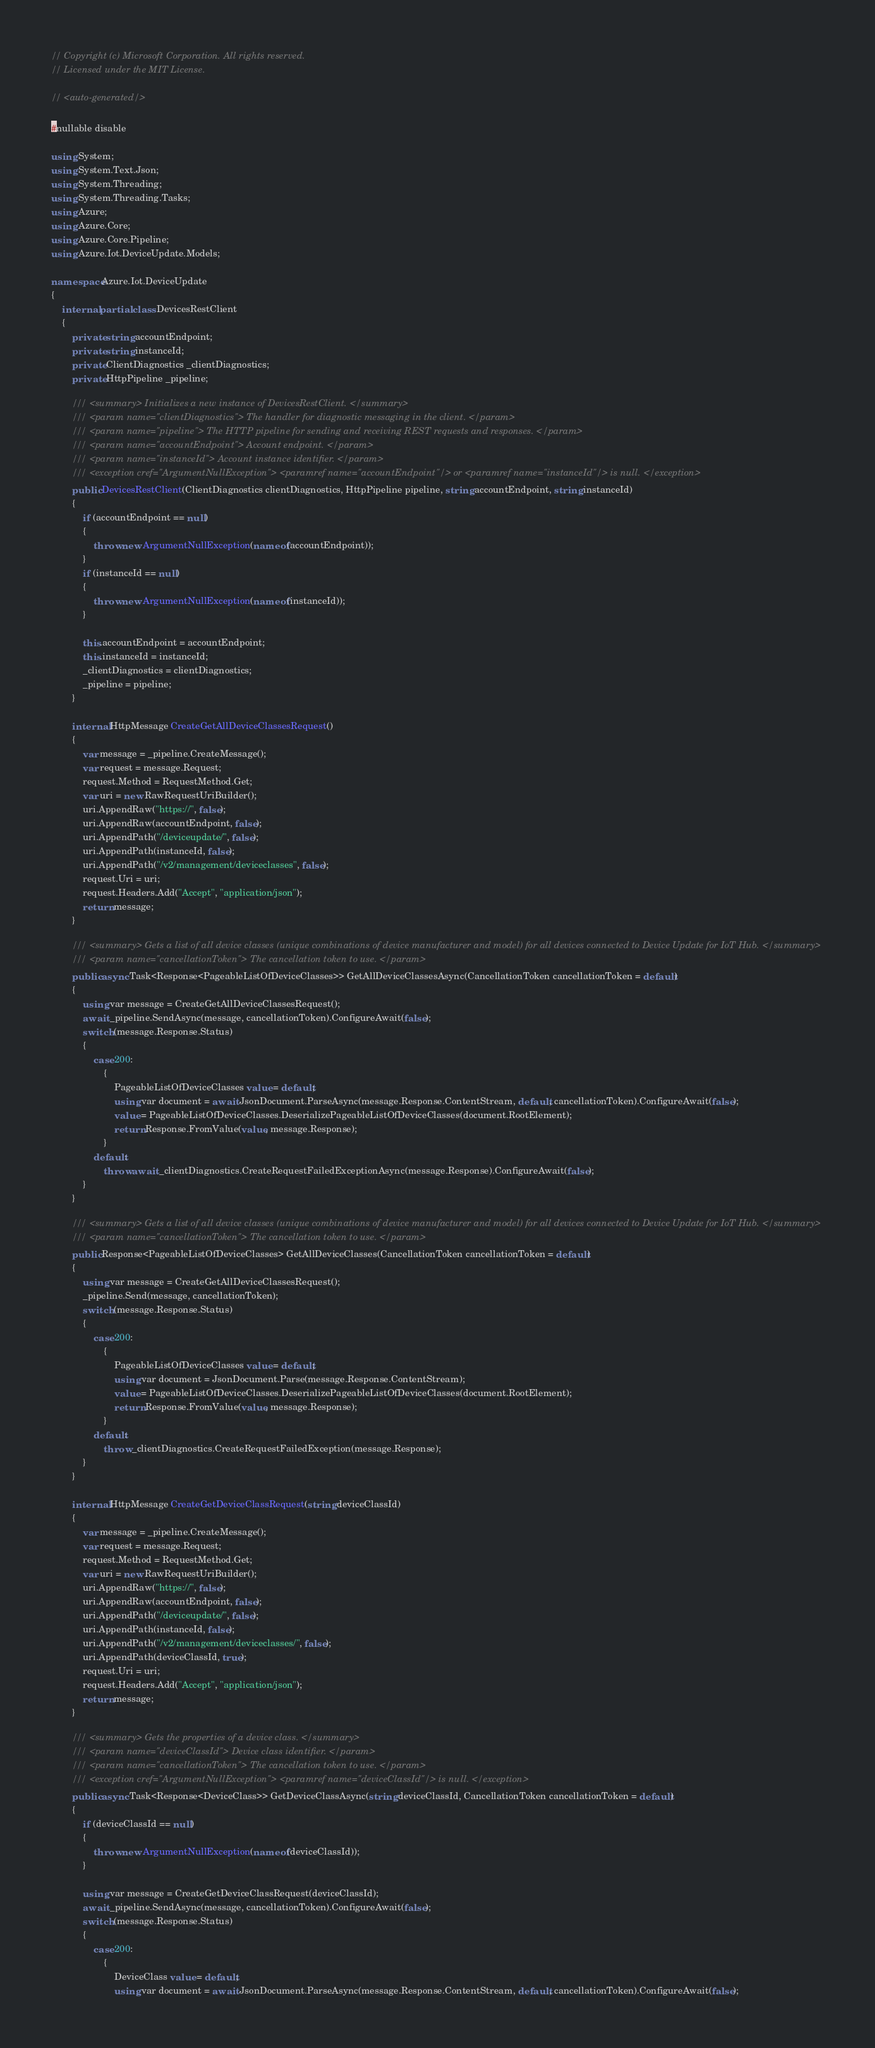<code> <loc_0><loc_0><loc_500><loc_500><_C#_>// Copyright (c) Microsoft Corporation. All rights reserved.
// Licensed under the MIT License.

// <auto-generated/>

#nullable disable

using System;
using System.Text.Json;
using System.Threading;
using System.Threading.Tasks;
using Azure;
using Azure.Core;
using Azure.Core.Pipeline;
using Azure.Iot.DeviceUpdate.Models;

namespace Azure.Iot.DeviceUpdate
{
    internal partial class DevicesRestClient
    {
        private string accountEndpoint;
        private string instanceId;
        private ClientDiagnostics _clientDiagnostics;
        private HttpPipeline _pipeline;

        /// <summary> Initializes a new instance of DevicesRestClient. </summary>
        /// <param name="clientDiagnostics"> The handler for diagnostic messaging in the client. </param>
        /// <param name="pipeline"> The HTTP pipeline for sending and receiving REST requests and responses. </param>
        /// <param name="accountEndpoint"> Account endpoint. </param>
        /// <param name="instanceId"> Account instance identifier. </param>
        /// <exception cref="ArgumentNullException"> <paramref name="accountEndpoint"/> or <paramref name="instanceId"/> is null. </exception>
        public DevicesRestClient(ClientDiagnostics clientDiagnostics, HttpPipeline pipeline, string accountEndpoint, string instanceId)
        {
            if (accountEndpoint == null)
            {
                throw new ArgumentNullException(nameof(accountEndpoint));
            }
            if (instanceId == null)
            {
                throw new ArgumentNullException(nameof(instanceId));
            }

            this.accountEndpoint = accountEndpoint;
            this.instanceId = instanceId;
            _clientDiagnostics = clientDiagnostics;
            _pipeline = pipeline;
        }

        internal HttpMessage CreateGetAllDeviceClassesRequest()
        {
            var message = _pipeline.CreateMessage();
            var request = message.Request;
            request.Method = RequestMethod.Get;
            var uri = new RawRequestUriBuilder();
            uri.AppendRaw("https://", false);
            uri.AppendRaw(accountEndpoint, false);
            uri.AppendPath("/deviceupdate/", false);
            uri.AppendPath(instanceId, false);
            uri.AppendPath("/v2/management/deviceclasses", false);
            request.Uri = uri;
            request.Headers.Add("Accept", "application/json");
            return message;
        }

        /// <summary> Gets a list of all device classes (unique combinations of device manufacturer and model) for all devices connected to Device Update for IoT Hub. </summary>
        /// <param name="cancellationToken"> The cancellation token to use. </param>
        public async Task<Response<PageableListOfDeviceClasses>> GetAllDeviceClassesAsync(CancellationToken cancellationToken = default)
        {
            using var message = CreateGetAllDeviceClassesRequest();
            await _pipeline.SendAsync(message, cancellationToken).ConfigureAwait(false);
            switch (message.Response.Status)
            {
                case 200:
                    {
                        PageableListOfDeviceClasses value = default;
                        using var document = await JsonDocument.ParseAsync(message.Response.ContentStream, default, cancellationToken).ConfigureAwait(false);
                        value = PageableListOfDeviceClasses.DeserializePageableListOfDeviceClasses(document.RootElement);
                        return Response.FromValue(value, message.Response);
                    }
                default:
                    throw await _clientDiagnostics.CreateRequestFailedExceptionAsync(message.Response).ConfigureAwait(false);
            }
        }

        /// <summary> Gets a list of all device classes (unique combinations of device manufacturer and model) for all devices connected to Device Update for IoT Hub. </summary>
        /// <param name="cancellationToken"> The cancellation token to use. </param>
        public Response<PageableListOfDeviceClasses> GetAllDeviceClasses(CancellationToken cancellationToken = default)
        {
            using var message = CreateGetAllDeviceClassesRequest();
            _pipeline.Send(message, cancellationToken);
            switch (message.Response.Status)
            {
                case 200:
                    {
                        PageableListOfDeviceClasses value = default;
                        using var document = JsonDocument.Parse(message.Response.ContentStream);
                        value = PageableListOfDeviceClasses.DeserializePageableListOfDeviceClasses(document.RootElement);
                        return Response.FromValue(value, message.Response);
                    }
                default:
                    throw _clientDiagnostics.CreateRequestFailedException(message.Response);
            }
        }

        internal HttpMessage CreateGetDeviceClassRequest(string deviceClassId)
        {
            var message = _pipeline.CreateMessage();
            var request = message.Request;
            request.Method = RequestMethod.Get;
            var uri = new RawRequestUriBuilder();
            uri.AppendRaw("https://", false);
            uri.AppendRaw(accountEndpoint, false);
            uri.AppendPath("/deviceupdate/", false);
            uri.AppendPath(instanceId, false);
            uri.AppendPath("/v2/management/deviceclasses/", false);
            uri.AppendPath(deviceClassId, true);
            request.Uri = uri;
            request.Headers.Add("Accept", "application/json");
            return message;
        }

        /// <summary> Gets the properties of a device class. </summary>
        /// <param name="deviceClassId"> Device class identifier. </param>
        /// <param name="cancellationToken"> The cancellation token to use. </param>
        /// <exception cref="ArgumentNullException"> <paramref name="deviceClassId"/> is null. </exception>
        public async Task<Response<DeviceClass>> GetDeviceClassAsync(string deviceClassId, CancellationToken cancellationToken = default)
        {
            if (deviceClassId == null)
            {
                throw new ArgumentNullException(nameof(deviceClassId));
            }

            using var message = CreateGetDeviceClassRequest(deviceClassId);
            await _pipeline.SendAsync(message, cancellationToken).ConfigureAwait(false);
            switch (message.Response.Status)
            {
                case 200:
                    {
                        DeviceClass value = default;
                        using var document = await JsonDocument.ParseAsync(message.Response.ContentStream, default, cancellationToken).ConfigureAwait(false);</code> 